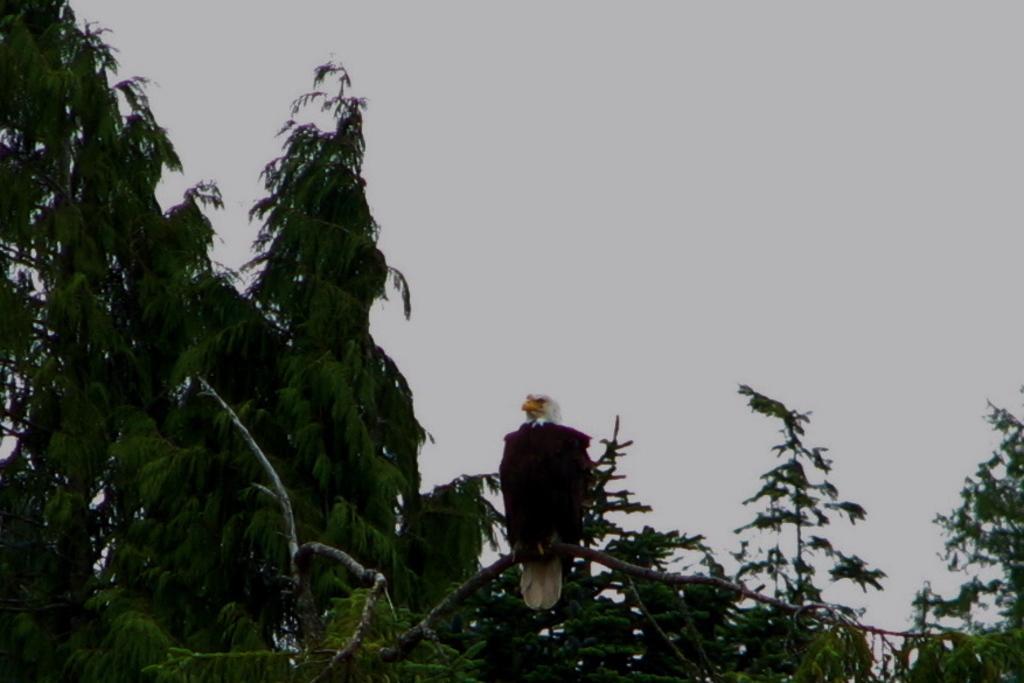Please provide a concise description of this image. In the center of the image we can see a bird is present on a stem. In the background of the image we can see the trees. At the top of the image we can see the sky. 